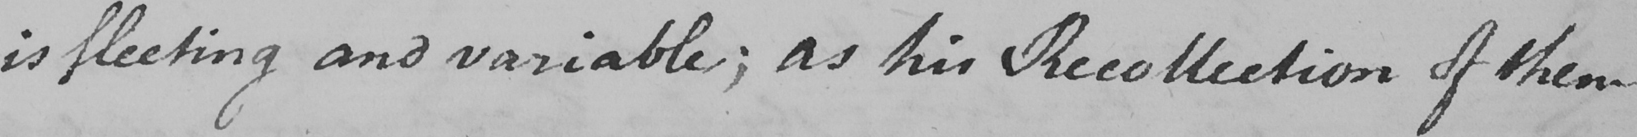What does this handwritten line say? is fleeting and variable ; as his Recollection of them 